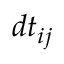<formula> <loc_0><loc_0><loc_500><loc_500>d t _ { i j }</formula> 